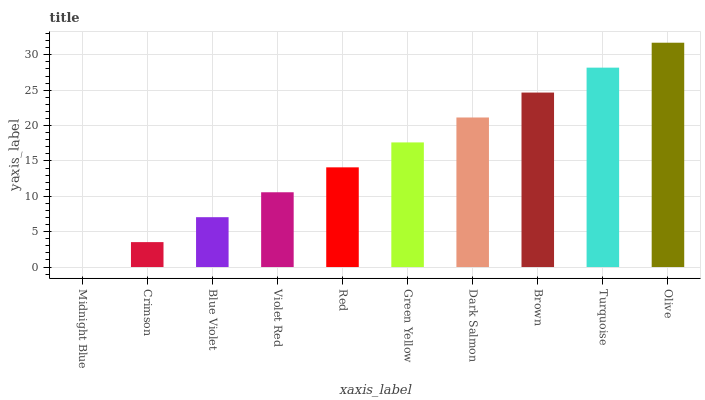Is Midnight Blue the minimum?
Answer yes or no. Yes. Is Olive the maximum?
Answer yes or no. Yes. Is Crimson the minimum?
Answer yes or no. No. Is Crimson the maximum?
Answer yes or no. No. Is Crimson greater than Midnight Blue?
Answer yes or no. Yes. Is Midnight Blue less than Crimson?
Answer yes or no. Yes. Is Midnight Blue greater than Crimson?
Answer yes or no. No. Is Crimson less than Midnight Blue?
Answer yes or no. No. Is Green Yellow the high median?
Answer yes or no. Yes. Is Red the low median?
Answer yes or no. Yes. Is Violet Red the high median?
Answer yes or no. No. Is Green Yellow the low median?
Answer yes or no. No. 